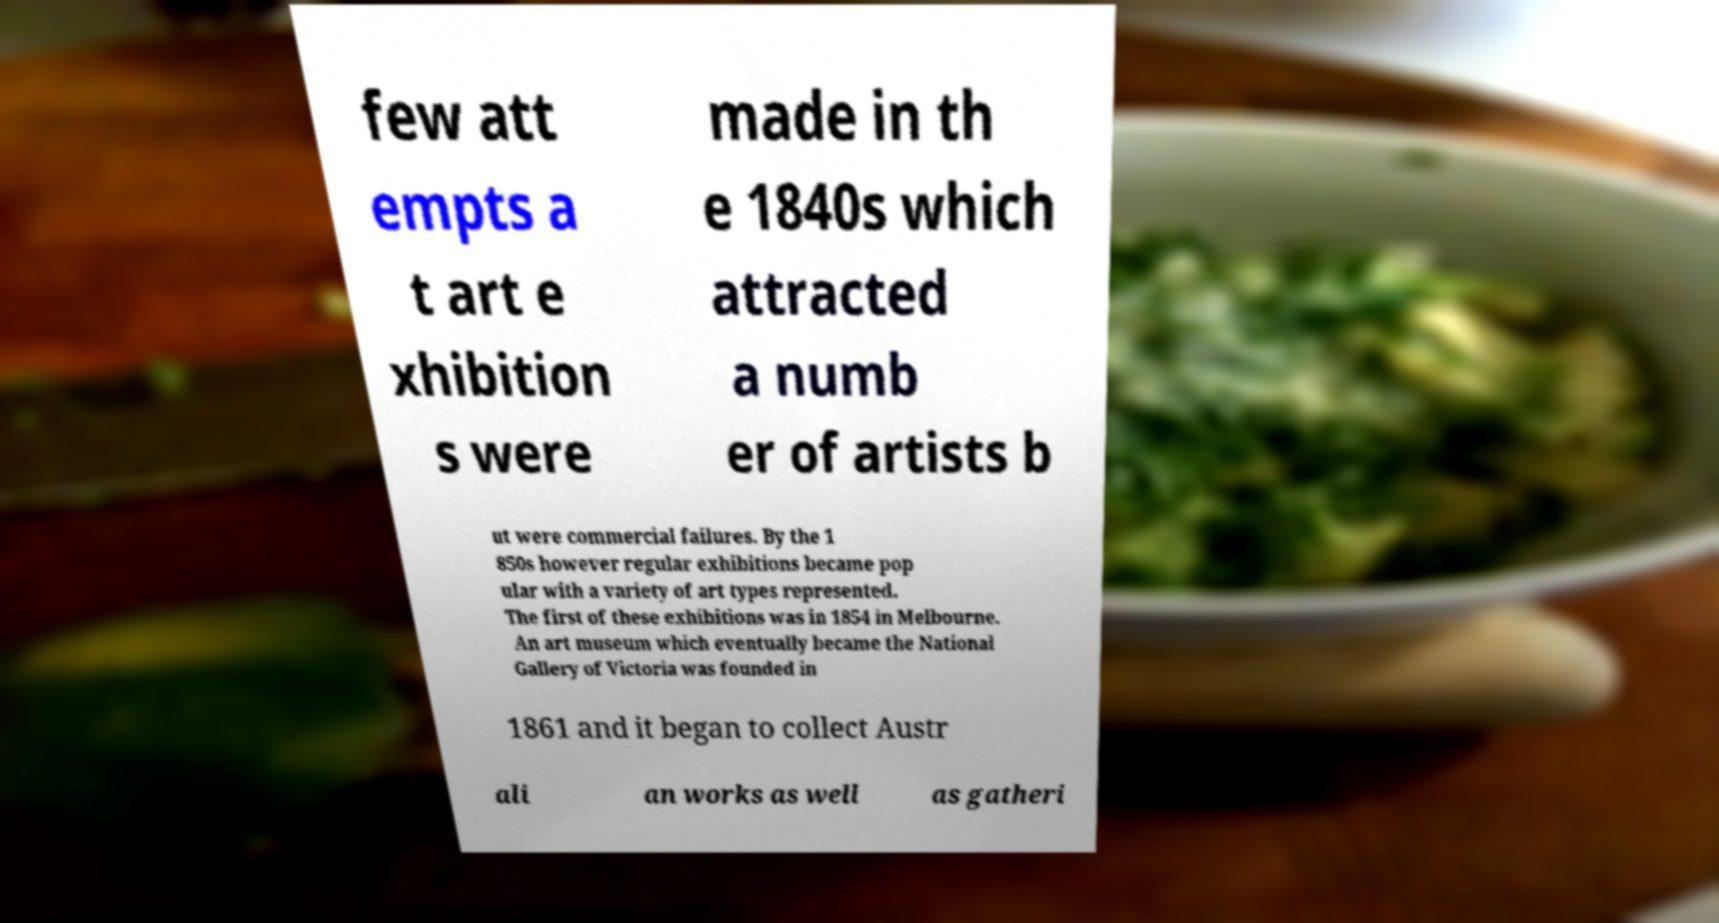Can you read and provide the text displayed in the image?This photo seems to have some interesting text. Can you extract and type it out for me? few att empts a t art e xhibition s were made in th e 1840s which attracted a numb er of artists b ut were commercial failures. By the 1 850s however regular exhibitions became pop ular with a variety of art types represented. The first of these exhibitions was in 1854 in Melbourne. An art museum which eventually became the National Gallery of Victoria was founded in 1861 and it began to collect Austr ali an works as well as gatheri 